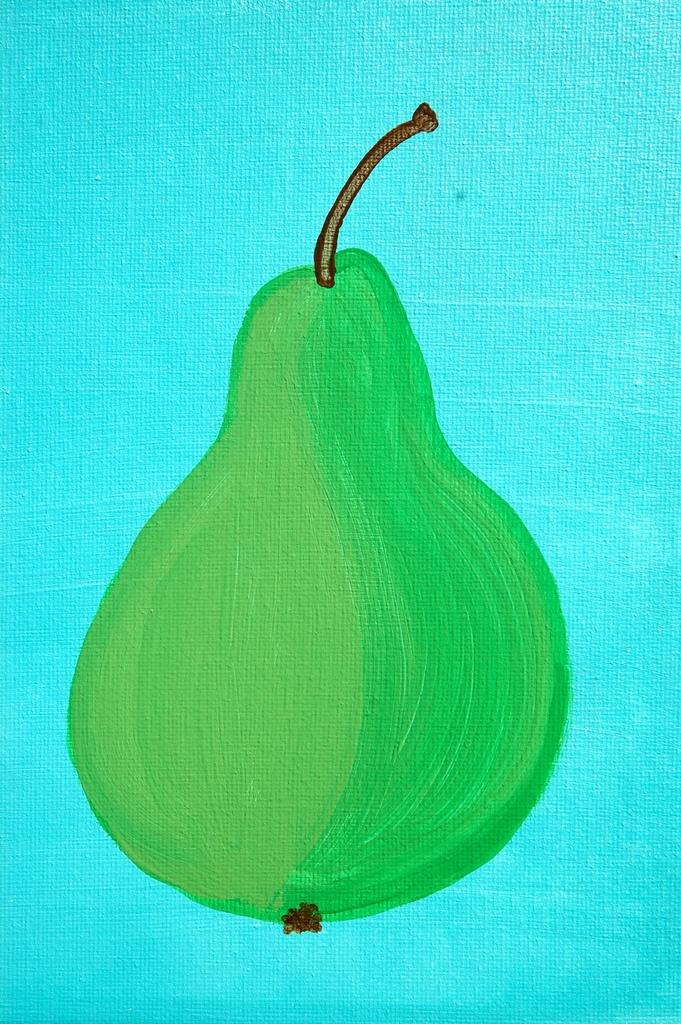What is depicted in the image? There is a drawing of a fruit in the image. What color is the background of the image? The background of the image is blue. What type of sack is being used to carry the fruit in the image? There is no sack present in the image; it only features a drawing of a fruit. 